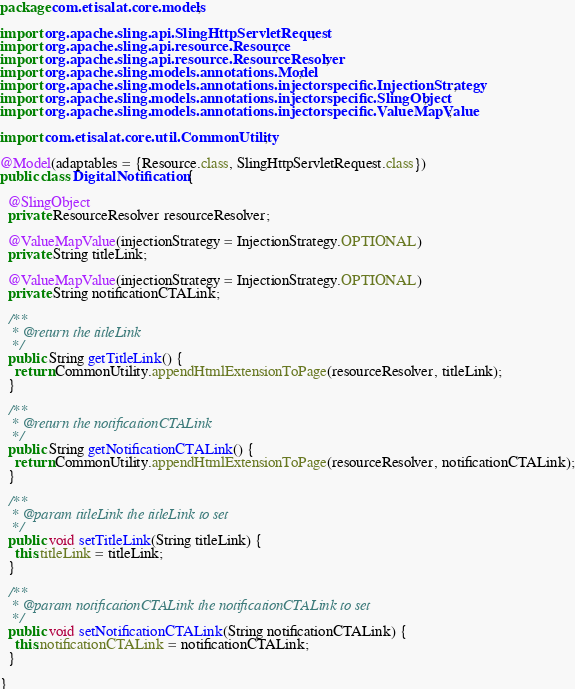Convert code to text. <code><loc_0><loc_0><loc_500><loc_500><_Java_>package com.etisalat.core.models;

import org.apache.sling.api.SlingHttpServletRequest;
import org.apache.sling.api.resource.Resource;
import org.apache.sling.api.resource.ResourceResolver;
import org.apache.sling.models.annotations.Model;
import org.apache.sling.models.annotations.injectorspecific.InjectionStrategy;
import org.apache.sling.models.annotations.injectorspecific.SlingObject;
import org.apache.sling.models.annotations.injectorspecific.ValueMapValue;

import com.etisalat.core.util.CommonUtility;

@Model(adaptables = {Resource.class, SlingHttpServletRequest.class})
public class DigitalNotification {

  @SlingObject
  private ResourceResolver resourceResolver;

  @ValueMapValue(injectionStrategy = InjectionStrategy.OPTIONAL)
  private String titleLink;

  @ValueMapValue(injectionStrategy = InjectionStrategy.OPTIONAL)
  private String notificationCTALink;

  /**
   * @return the titleLink
   */
  public String getTitleLink() {
    return CommonUtility.appendHtmlExtensionToPage(resourceResolver, titleLink);
  }

  /**
   * @return the notificationCTALink
   */
  public String getNotificationCTALink() {
    return CommonUtility.appendHtmlExtensionToPage(resourceResolver, notificationCTALink);
  }

  /**
   * @param titleLink the titleLink to set
   */
  public void setTitleLink(String titleLink) {
    this.titleLink = titleLink;
  }

  /**
   * @param notificationCTALink the notificationCTALink to set
   */
  public void setNotificationCTALink(String notificationCTALink) {
    this.notificationCTALink = notificationCTALink;
  }

}
</code> 